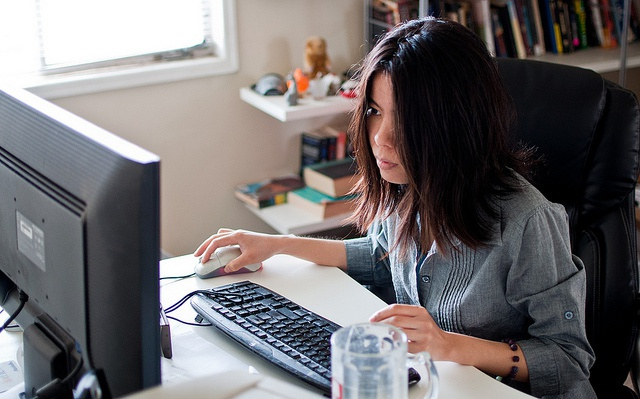Describe the objects in this image and their specific colors. I can see people in white, black, gray, salmon, and darkgray tones, tv in white, black, and gray tones, chair in white, black, and gray tones, book in white, black, gray, and maroon tones, and keyboard in white, black, lightgray, and gray tones in this image. 